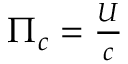Convert formula to latex. <formula><loc_0><loc_0><loc_500><loc_500>\begin{array} { r } { \Pi _ { c } = \frac { U } { c } } \end{array}</formula> 